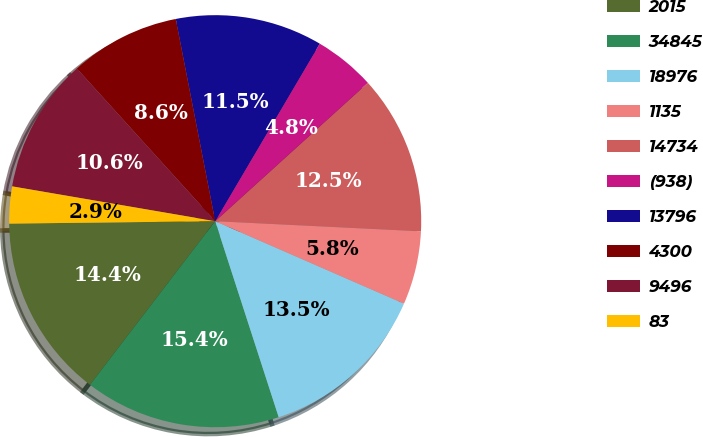<chart> <loc_0><loc_0><loc_500><loc_500><pie_chart><fcel>2015<fcel>34845<fcel>18976<fcel>1135<fcel>14734<fcel>(938)<fcel>13796<fcel>4300<fcel>9496<fcel>83<nl><fcel>14.42%<fcel>15.38%<fcel>13.46%<fcel>5.77%<fcel>12.5%<fcel>4.81%<fcel>11.54%<fcel>8.65%<fcel>10.58%<fcel>2.89%<nl></chart> 